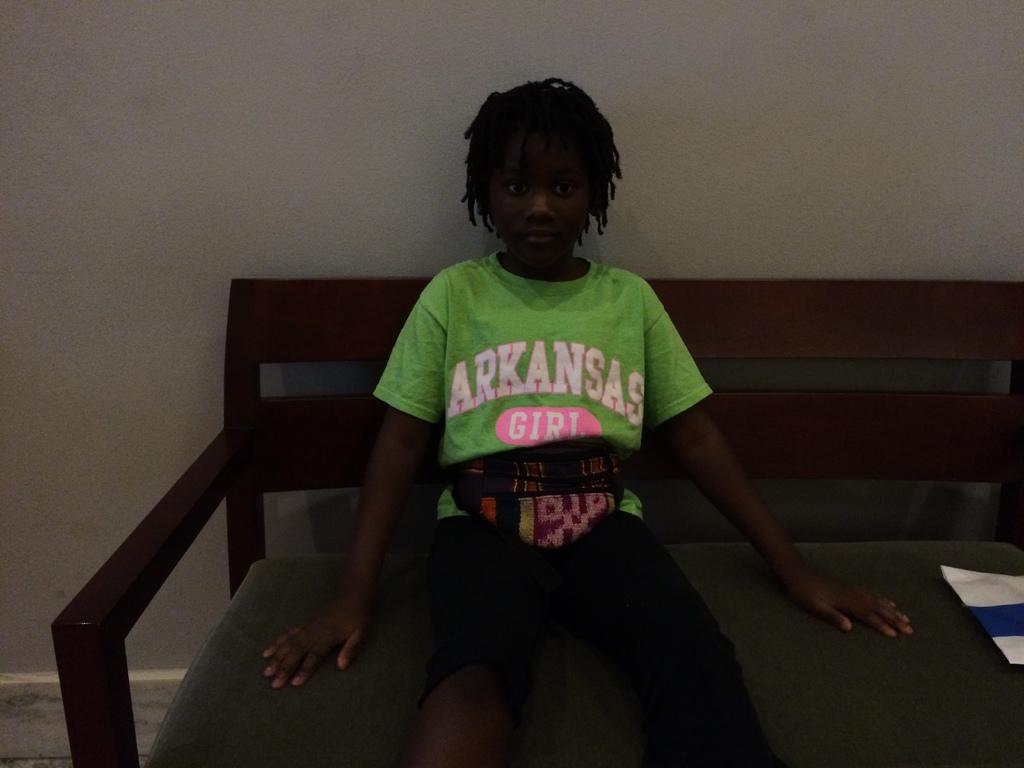Who is the main subject in the image? There is a girl in the image. What is the girl doing in the image? The girl is sitting on a bench. What is the girl wearing in the image? The girl is wearing a green t-shirt. What can be seen in the background of the image? There is a wall visible in the image. What type of organization is the girl a part of in the image? There is no indication in the image that the girl is a part of any organization. 